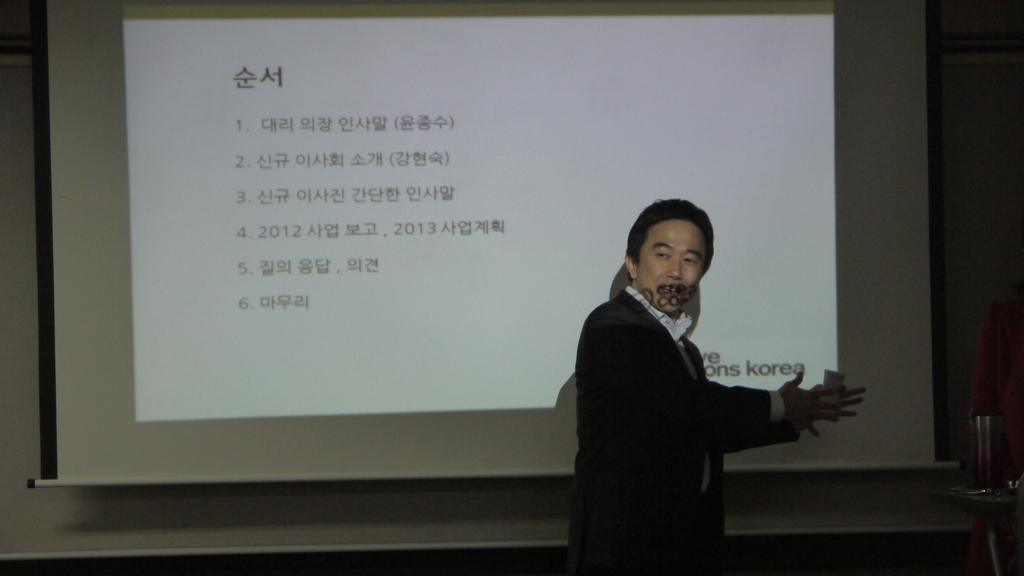Who is present in the image? There is a man in the image. What is the man wearing? The man is wearing a black suit. What is the man's posture in the image? The man is standing. What can be seen behind the man? There is a screen behind the man. What is displayed on the screen? There are texts visible on the screen. Is there a bear in jail visible in the image? No, there is no bear or jail present in the image. Can you see any bones in the image? No, there are no bones visible in the image. 